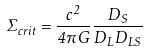Convert formula to latex. <formula><loc_0><loc_0><loc_500><loc_500>\Sigma _ { c r i t } = \frac { c ^ { 2 } } { 4 \pi G } \frac { D _ { S } } { D _ { L } D _ { L S } }</formula> 